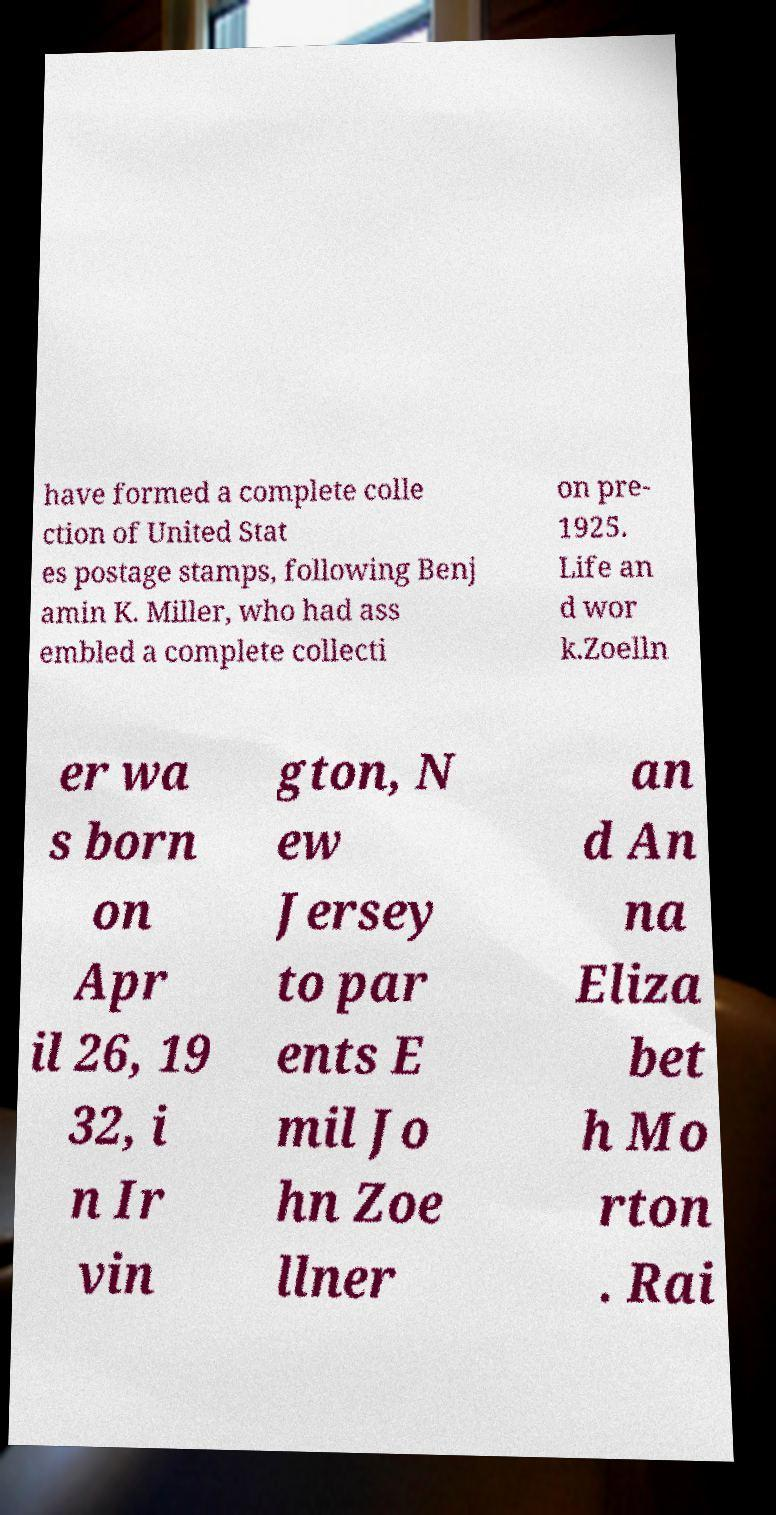Please read and relay the text visible in this image. What does it say? have formed a complete colle ction of United Stat es postage stamps, following Benj amin K. Miller, who had ass embled a complete collecti on pre- 1925. Life an d wor k.Zoelln er wa s born on Apr il 26, 19 32, i n Ir vin gton, N ew Jersey to par ents E mil Jo hn Zoe llner an d An na Eliza bet h Mo rton . Rai 